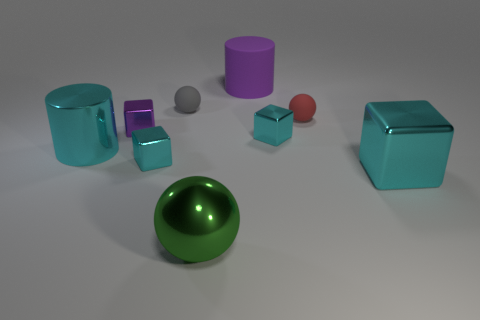Subtract all cyan blocks. How many were subtracted if there are1cyan blocks left? 2 Subtract all large cyan metallic blocks. How many blocks are left? 3 Add 1 tiny objects. How many objects exist? 10 Subtract all purple cubes. How many cubes are left? 3 Subtract 0 yellow cubes. How many objects are left? 9 Subtract all spheres. How many objects are left? 6 Subtract 2 cylinders. How many cylinders are left? 0 Subtract all cyan cubes. Subtract all red balls. How many cubes are left? 1 Subtract all green cubes. How many green cylinders are left? 0 Subtract all large gray metal balls. Subtract all purple cylinders. How many objects are left? 8 